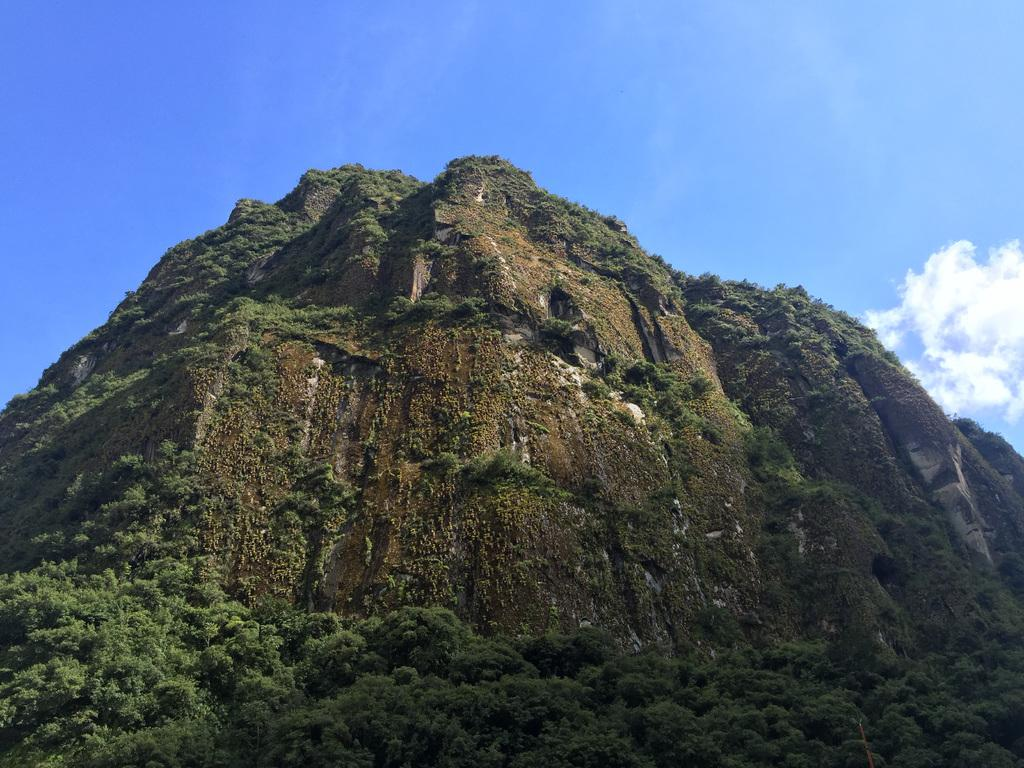What is the main subject of the picture? The main subject of the picture is a mountain. What can be seen on the mountain? The mountain has trees and plants on it. Who is the expert on the distribution of things in the image? There is no specific expert mentioned in the image, and the term "distribution of things" is not relevant to the image's content. 